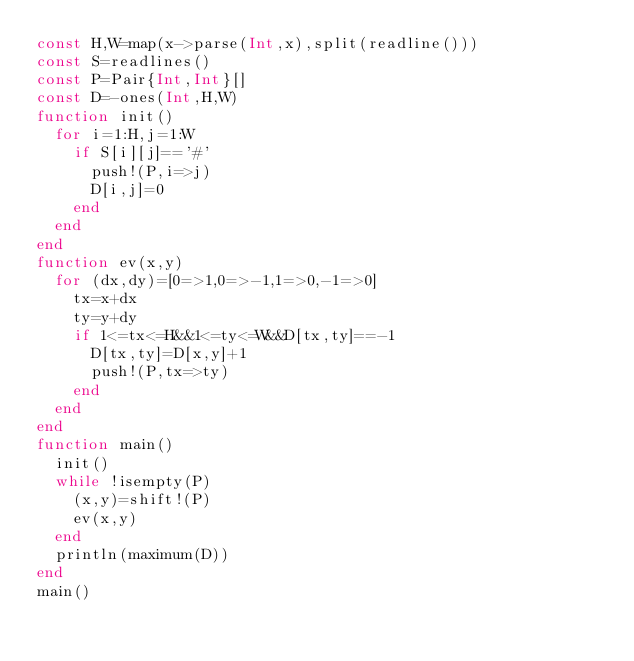<code> <loc_0><loc_0><loc_500><loc_500><_Julia_>const H,W=map(x->parse(Int,x),split(readline()))
const S=readlines()
const P=Pair{Int,Int}[]
const D=-ones(Int,H,W)
function init()
	for i=1:H,j=1:W
		if S[i][j]=='#'
			push!(P,i=>j)
			D[i,j]=0
		end
	end
end
function ev(x,y)
	for (dx,dy)=[0=>1,0=>-1,1=>0,-1=>0]
		tx=x+dx
		ty=y+dy
		if 1<=tx<=H&&1<=ty<=W&&D[tx,ty]==-1
			D[tx,ty]=D[x,y]+1
			push!(P,tx=>ty)
		end
	end
end
function main()
	init()
	while !isempty(P)
		(x,y)=shift!(P)
		ev(x,y)
	end
	println(maximum(D))
end
main()</code> 